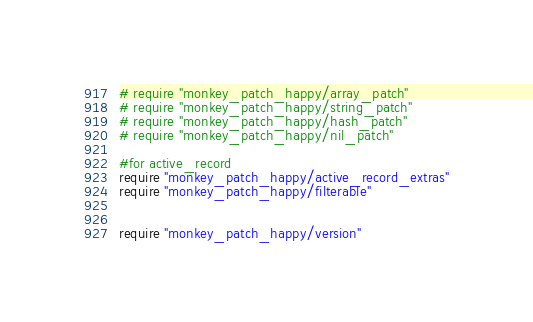Convert code to text. <code><loc_0><loc_0><loc_500><loc_500><_Ruby_># require "monkey_patch_happy/array_patch"
# require "monkey_patch_happy/string_patch"
# require "monkey_patch_happy/hash_patch"
# require "monkey_patch_happy/nil_patch"

#for active_record
require "monkey_patch_happy/active_record_extras"
require "monkey_patch_happy/filterable"


require "monkey_patch_happy/version"

</code> 